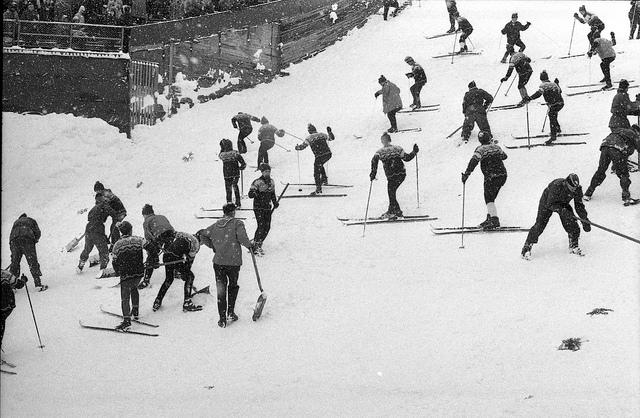Is it summer?
Keep it brief. No. What time of year was the picture taken of the skiers?
Concise answer only. Winter. Is the picture in black and white?
Answer briefly. Yes. 